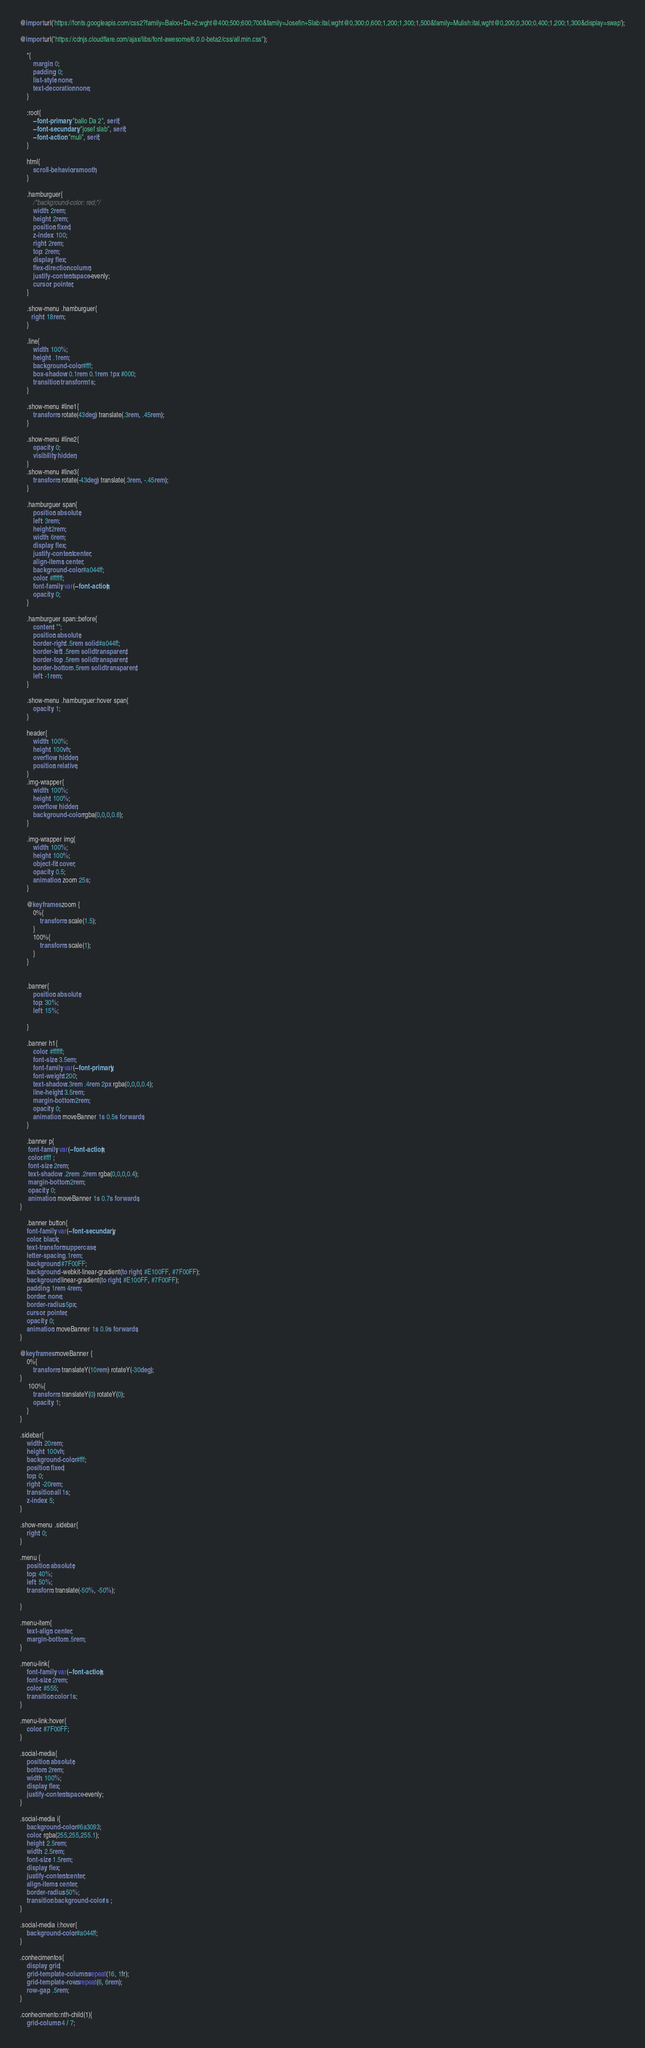<code> <loc_0><loc_0><loc_500><loc_500><_CSS_>@import url('https://fonts.googleapis.com/css2?family=Baloo+Da+2:wght@400;500;600;700&family=Josefin+Slab:ital,wght@0,300;0,600;1,200;1,300;1,500&family=Mulish:ital,wght@0,200;0,300;0,400;1,200;1,300&display=swap');

@import url("https://cdnjs.cloudflare.com/ajax/libs/font-awesome/6.0.0-beta2/css/all.min.css");

    *{
        margin: 0;
        padding: 0;
        list-style: none;
        text-decoration: none;
    }

    :root{
        --font-primary: "ballo Da 2", serif;
        --font-secundary: "josef slab", serif;
        --font-action: "muli", serif;
    }

    html{
        scroll-behavior: smooth;
    }

    .hamburguer{
        /*background-color: red;*/
        width: 2rem;
        height: 2rem;
        position: fixed;
        z-index: 100;
        right: 2rem;
        top: 2rem;
        display: flex;
        flex-direction: column;
        justify-content: space-evenly;
        cursor: pointer;
    }

    .show-menu .hamburguer{
       right: 18rem;
    }

    .line{
        width: 100%;
        height: .1rem;
        background-color: #fff;
        box-shadow: 0.1rem 0.1rem 1px #000;
        transition: transform 1s;
    }

    .show-menu #line1{
        transform: rotate(43deg) translate(.3rem, .45rem);
    }

    .show-menu #line2{
        opacity: 0;
        visibility: hidden;
    }
    .show-menu #line3{
        transform: rotate(-43deg) translate(.3rem, -.45rem);
    }

    .hamburguer span{
        position: absolute;
        left: 3rem;
        height:2rem;
        width: 6rem;
        display: flex;
        justify-content: center;
        align-items: center;
        background-color: #a044ff;
        color: #ffffff;
        font-family: var(--font-action);
        opacity: 0;
    }

    .hamburguer span::before{
        content: "";
        position: absolute;
        border-right: .5rem solid #a044ff;
        border-left: .5rem solid transparent;
        border-top: .5rem solid transparent;
        border-bottom: .5rem solid transparent;
        left: -1rem;
    }

    .show-menu .hamburguer:hover span{
        opacity: 1;
    }

    header{
        width: 100%;
        height: 100vh;
        overflow: hidden;
        position: relative;     
    }
    .img-wrapper{
        width: 100%;
        height: 100%;
        overflow: hidden;
        background-color: rgba(0,0,0,0.8);
    }

    .img-wrapper img{
        width: 100%;
        height: 100%;
        object-fit: cover;
        opacity: 0.5;
        animation: zoom 25s;
    }

    @keyframes zoom {
        0%{
            transform: scale(1.5);
        }
        100%{
            transform: scale(1);
        }
    }


    .banner{
        position: absolute;
        top: 30%;
        left: 15%;
        
    }

    .banner h1{
        color: #ffffff;
        font-size: 3.5em;
        font-family: var(--font-primary);
        font-weight: 200;
        text-shadow:.3rem .4rem 2px rgba(0,0,0,0.4);
        line-height: 3.5rem;
        margin-bottom: 2rem;
        opacity: 0;
        animation: moveBanner 1s 0.5s forwards;
    }

    .banner p{
     font-family: var(--font-action);
     color:#fff ;
     font-size: 2rem;
     text-shadow: .2rem .2rem rgba(0,0,0,0.4);
     margin-bottom: 2rem;
     opacity: 0;
     animation: moveBanner 1s 0.7s forwards;
}

    .banner button{
    font-family: var(--font-secundary);
    color: black;
    text-transform: uppercase;
    letter-spacing: .1rem;
    background: #7F00FF; 
    background: -webkit-linear-gradient(to right, #E100FF, #7F00FF); 
    background: linear-gradient(to right, #E100FF, #7F00FF);
    padding: 1rem 4rem;
    border: none;
    border-radius: 5px;
    cursor: pointer;
    opacity: 0;
    animation: moveBanner 1s 0.9s forwards;
}

@keyframes moveBanner {
    0%{
        transform: translateY(10rem) rotateY(-30deg);
}
     100%{
        transform: translateY(0) rotateY(0);
        opacity: 1;
    }
}

.sidebar{
    width: 20rem;
    height: 100vh;
    background-color: #fff;
    position: fixed;
    top: 0;
    right: -20rem;
    transition: all 1s;
    z-index: 5;
}

.show-menu .sidebar{
    right: 0;
}

.menu {
    position: absolute;
    top: 40%;
    left: 50%;
    transform: translate(-50%, -50%);

}

.menu-item{
    text-align: center;
    margin-bottom: .5rem;
}

.menu-link{
    font-family: var(--font-action);
    font-size: 2rem;
    color: #555;
    transition: color 1s;
}

.menu-link:hover{
    color: #7F00FF;
}

.social-media{
    position: absolute;
    bottom: 2rem;
    width: 100%;
    display: flex;
    justify-content: space-evenly;
}

.social-media i{
    background-color: #6a3093;
    color: rgba(255,255,255.1);
    height: 2.5rem;
    width: 2.5rem;
    font-size: 1.5rem;
    display: flex;
    justify-content: center;
    align-items: center;
    border-radius: 50%;
    transition: background-color 1s ;
}

.social-media i:hover{
    background-color: #a044ff;
}

.conhecimentos{
    display: grid;
    grid-template-columns: repeat(16, 1fr);
    grid-template-rows: repeat(6, 6rem);
    row-gap: .5rem;
}

.conhecimento:nth-child(1){
    grid-column: 4 / 7;</code> 